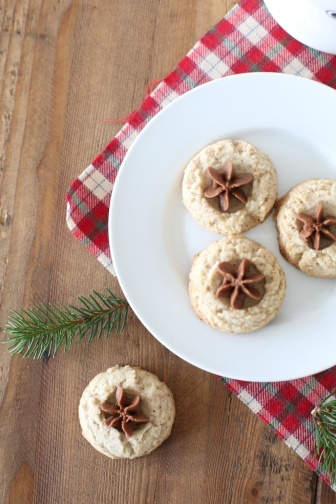What's happening in the scene? In the center of the image, a pristine white plate holds three light brown sugar cookies, each beautifully decorated with a dark brown star anise on top. The plate is placed on a vibrant red and white checkered napkin, which lies partially on a wooden surface extending to the left side of the image. To the right of the plate, a fourth cookie, also adorned with a star anise, is positioned, adding a symmetrical appeal to the presentation. A sprig of lush dark greenery is placed next to the solitary cookie, introducing a touch of nature and enhancing the aesthetic appeal of the scene. The overall arrangement evokes a festive or holiday atmosphere, with the star anise and greenery suggesting a seasonal theme filled with warmth and celebration. 